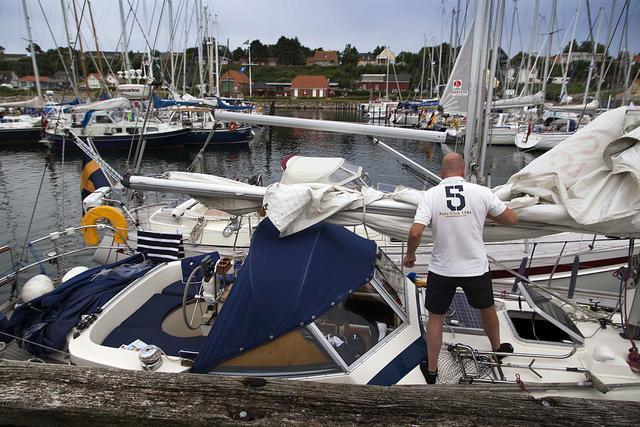How many boats are in the photo?
Give a very brief answer. 5. 